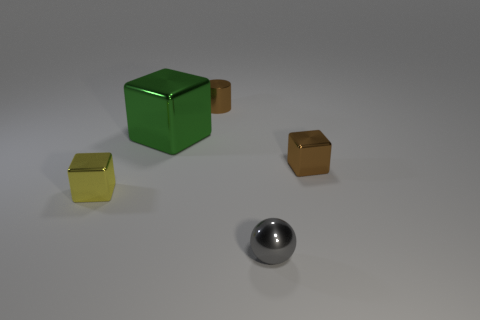Is there anything else that is the same size as the green metallic thing?
Keep it short and to the point. No. What material is the ball?
Provide a succinct answer. Metal. Is the number of yellow blocks that are right of the sphere greater than the number of tiny purple matte things?
Keep it short and to the point. No. How many gray things are left of the big block that is right of the small thing that is left of the small cylinder?
Give a very brief answer. 0. There is a cube that is to the left of the tiny brown shiny block and behind the small yellow shiny object; what material is it?
Offer a very short reply. Metal. What is the color of the shiny cylinder?
Give a very brief answer. Brown. Are there more large cubes behind the tiny gray shiny sphere than brown blocks on the left side of the small brown block?
Your answer should be very brief. Yes. There is a small shiny cube that is in front of the small brown block; what is its color?
Keep it short and to the point. Yellow. Does the brown metallic object in front of the small cylinder have the same size as the brown cylinder behind the green cube?
Offer a terse response. Yes. How many things are yellow metallic cubes or gray matte spheres?
Ensure brevity in your answer.  1. 